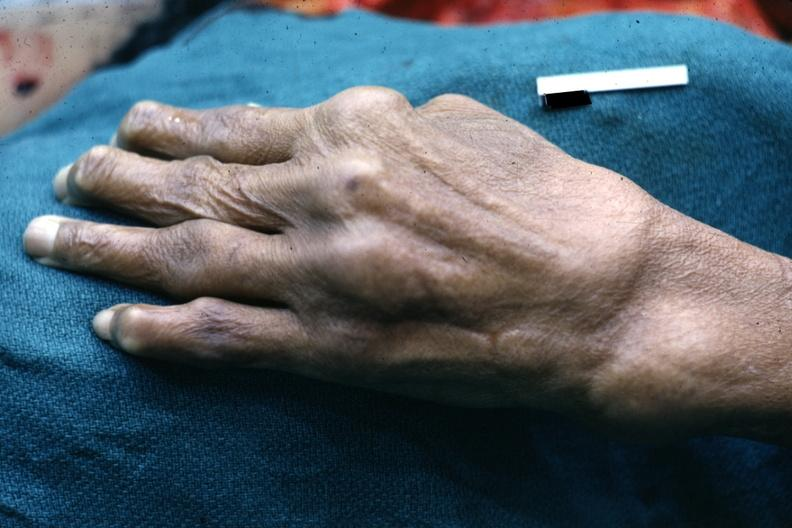does adenocarcinoma show enlarged joints typical of osteoarthritis?
Answer the question using a single word or phrase. No 